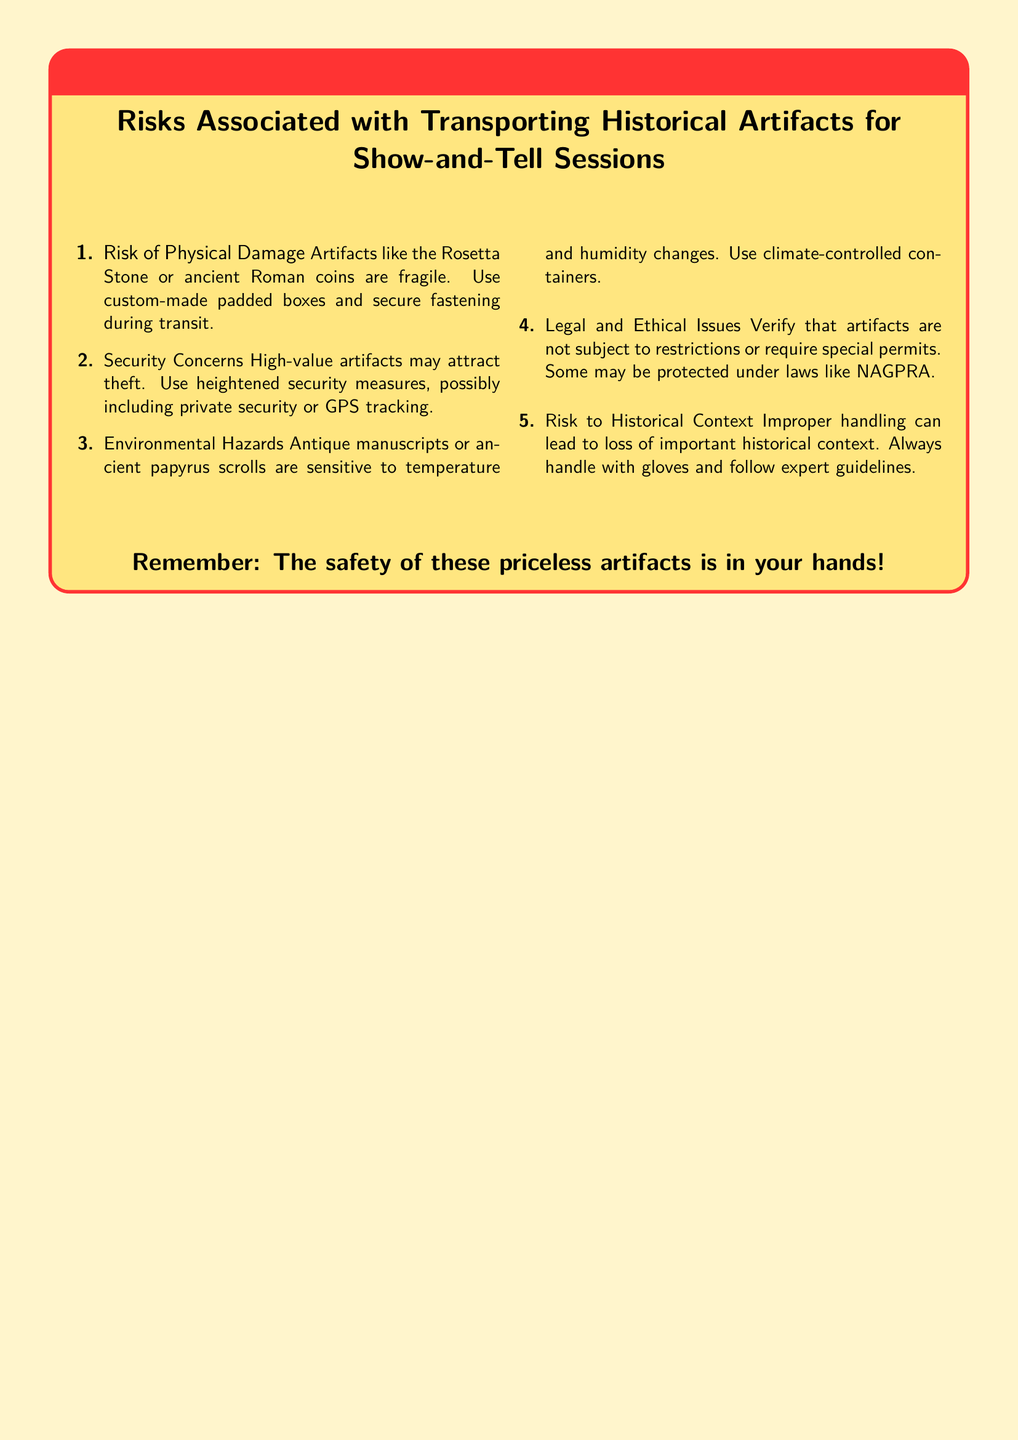What is the title of the warning label? The title of the warning label is prominently displayed in bold and indicates the subject matter of the document.
Answer: Risks Associated with Transporting Historical Artifacts for Show-and-Tell Sessions How many risks are listed in the document? The number of risks is given as a count within the enumerated list provided.
Answer: 5 What is the first listed risk? The first risk is the first item in the ordered list and outlines a specific concern regarding artifacts.
Answer: Risk of Physical Damage What should be used for fragile artifacts during transit? The document specifies protective measures to safeguard fragile artifacts.
Answer: Custom-made padded boxes What legal act is mentioned in the warning label? The legal aspect is covered in one of the risks and references a specific legislation.
Answer: NAGPRA What type of container is recommended for antique manuscripts? The document suggests a specific condition for transporting sensitive items, particularly regarding climate.
Answer: Climate-controlled containers What is emphasized regarding the handling of artifacts? This part of the document highlights an essential guideline for the physical interaction with historical items.
Answer: Always handle with gloves How is the overall tone of the document conveyed? The design elements and language used in the document portray a sense of urgency and care regarding the subject matter.
Answer: Warning! 